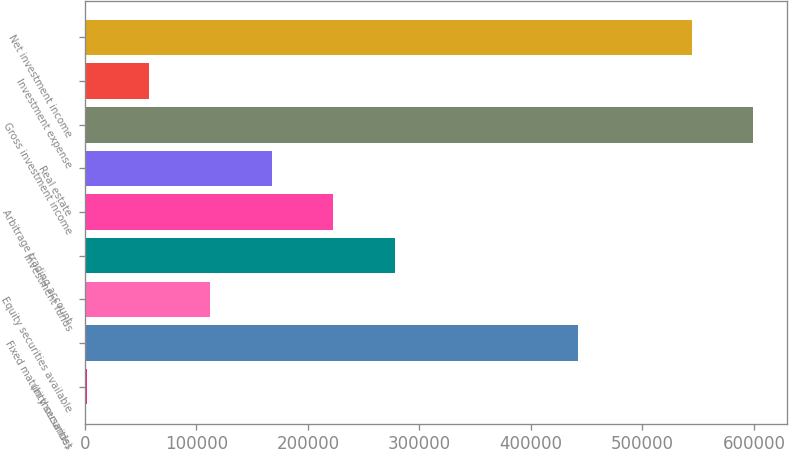<chart> <loc_0><loc_0><loc_500><loc_500><bar_chart><fcel>(In thousands)<fcel>Fixed maturity securities<fcel>Equity securities available<fcel>Investment funds<fcel>Arbitrage trading account<fcel>Real estate<fcel>Gross investment income<fcel>Investment expense<fcel>Net investment income<nl><fcel>2013<fcel>442287<fcel>112472<fcel>278160<fcel>222931<fcel>167702<fcel>599520<fcel>57242.5<fcel>544291<nl></chart> 